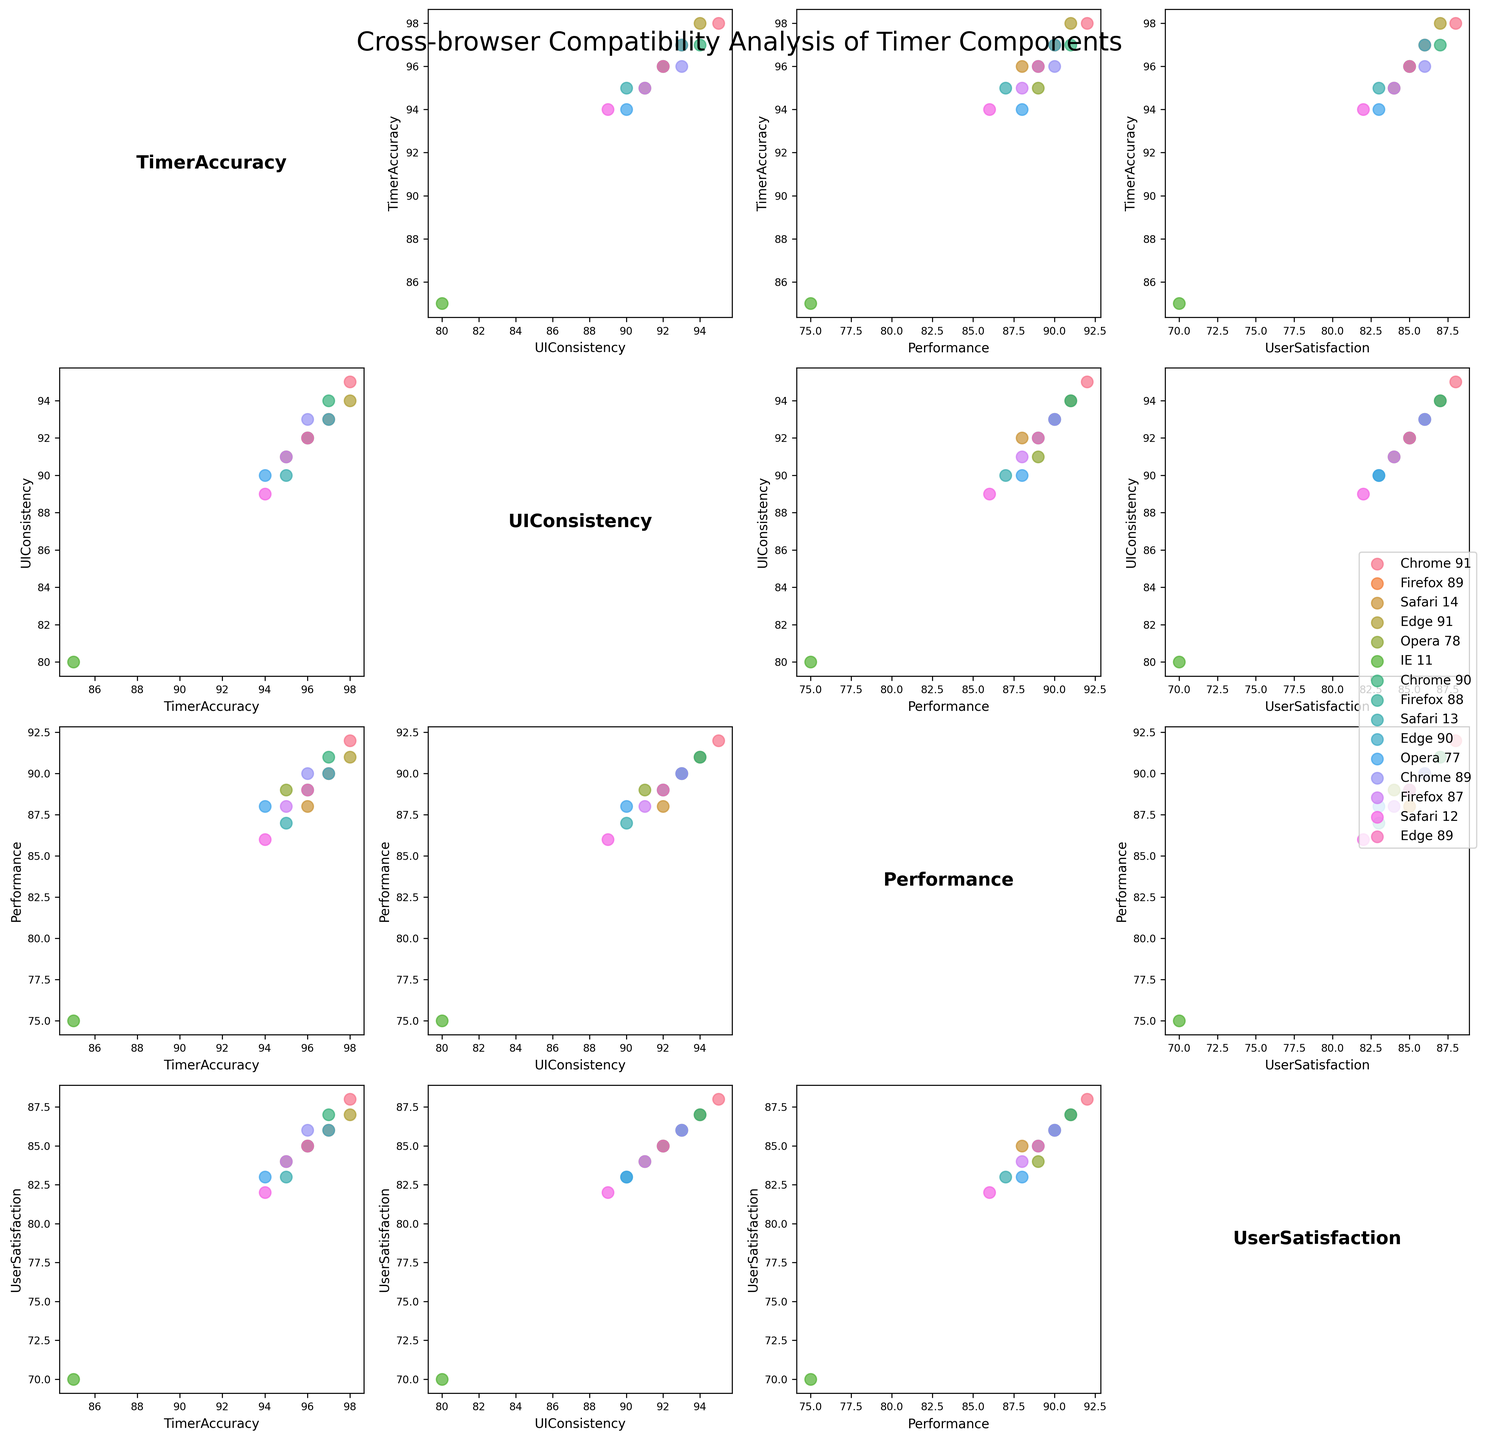What is the title of the figure? The figure has a title at the top, which is usually large and prominent. In this case, it states: "Cross-browser Compatibility Analysis of Timer Components"
Answer: Cross-browser Compatibility Analysis of Timer Components How many different browsers are represented in the scatterplot matrix? You can identify the number of unique data points labeled in the legend on the right side of the plot. Each unique color corresponds to a different browser, including versions. By counting these labels, we see there are six.
Answer: Six Which browser has the highest TimerAccuracy in the analyzed versions? Examine the scatter plot points along the TimerAccuracy axis. The point closest to the maximum value (98) corresponds to browsers in the matrix. By looking at these points, we see it's Chrome 91 or Edge 91. Both have TimerAccuracy of 98.
Answer: Chrome 91 or Edge 91 In which browser does UserSatisfaction seem to have the weakest performance? Compare UserSatisfaction values across all the browsers. The browser with the lowest points on the UserSatisfaction axis is IE 11 with a value of 70.
Answer: IE 11 What is the relationship between TimerAccuracy and UserSatisfaction for Firefox browsers? Look at the scatter plot where TimerAccuracy is the y-axis and UserSatisfaction is the x-axis. Locate the points corresponding to Firefox. They hover around high TimerAccuracy (95-97) and relatively high UserSatisfaction (84-86).
Answer: High TimerAccuracy, relatively high UserSatisfaction Which two browsers are most similar in terms of UIConsistency and Performance? Identify and compare points in the scatter plot sections where UIConsistency and Performance cross. The most aligned or closely plotted points represent the most similar browsers, which are Chrome 91 and Edge 91. Both score 95 & 94 respectively in UIConsistency and 92 & 91 in Performance.
Answer: Chrome 91 and Edge 91 What's the average TimerAccuracy across all versions of Opera? Locate the TimerAccuracy values for Opera (95 from 78, 94 from 77). Summing these values: 95 + 94 and dividing by 2 gives an average. (95 + 94) / 2 = 94.5
Answer: 94.5 Does Safari 14 perform better or worse than Safari 12 in UserSatisfaction? Compare the UserSatisfaction points for Safari 14 and Safari 12 on the scatter plot. Safari 14 has a UserSatisfaction of 85, while Safari 12 has 82. Thus, Safari 14 performs better.
Answer: Better Which browser has the widest disparity between UIConsistency and TimerAccuracy? Assess the difference by comparing the two values for each browser entry, noting the largest gap. The IE 11 browser scores 80 in UIConsistency and 85 in TimerAccuracy, a disparity of 15 points (the highest observed).
Answer: IE 11 